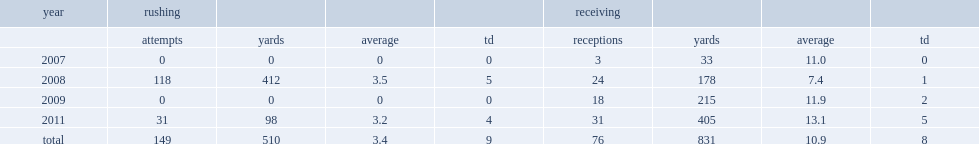How many rushing yards did lamark brown get in 2008? 412.0. Parse the full table. {'header': ['year', 'rushing', '', '', '', 'receiving', '', '', ''], 'rows': [['', 'attempts', 'yards', 'average', 'td', 'receptions', 'yards', 'average', 'td'], ['2007', '0', '0', '0', '0', '3', '33', '11.0', '0'], ['2008', '118', '412', '3.5', '5', '24', '178', '7.4', '1'], ['2009', '0', '0', '0', '0', '18', '215', '11.9', '2'], ['2011', '31', '98', '3.2', '4', '31', '405', '13.1', '5'], ['total', '149', '510', '3.4', '9', '76', '831', '10.9', '8']]} 